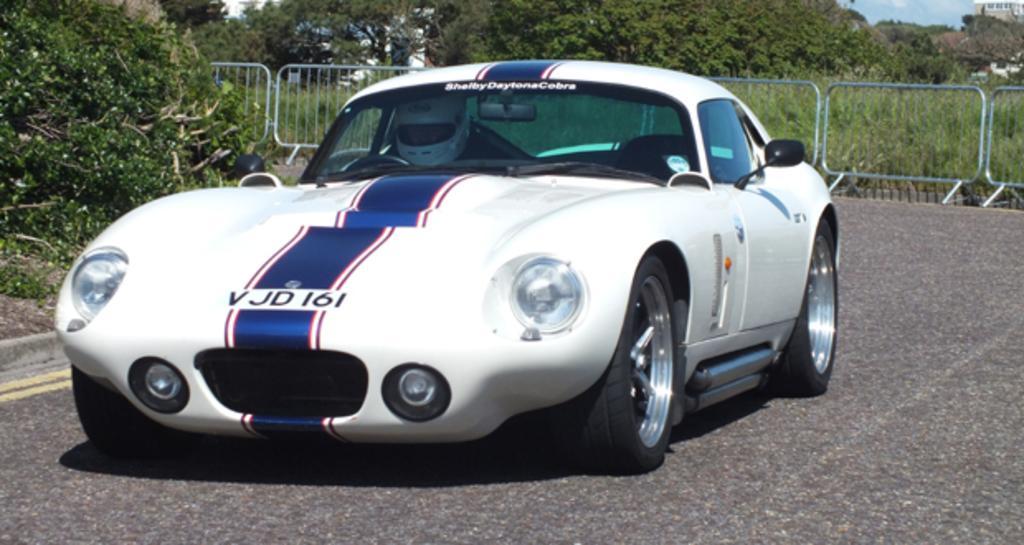Please provide a concise description of this image. In this image I can see the vehicle on the road. The vehicle is in white and blue color. I can see one person sitting inside the vehicle. In the back I can see the railing. And I can also see many trees and the sky in the back. 